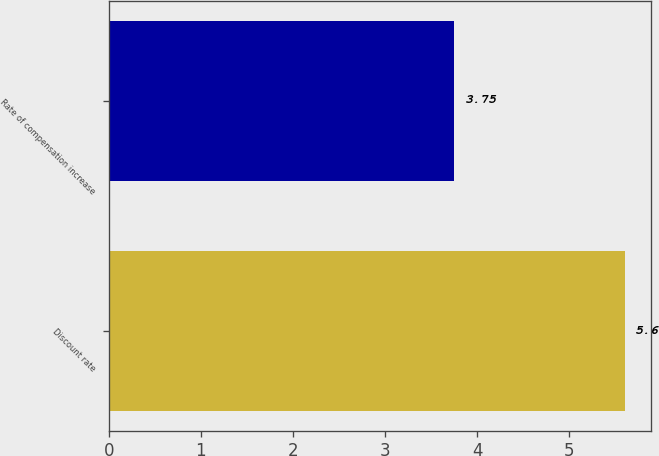Convert chart to OTSL. <chart><loc_0><loc_0><loc_500><loc_500><bar_chart><fcel>Discount rate<fcel>Rate of compensation increase<nl><fcel>5.6<fcel>3.75<nl></chart> 